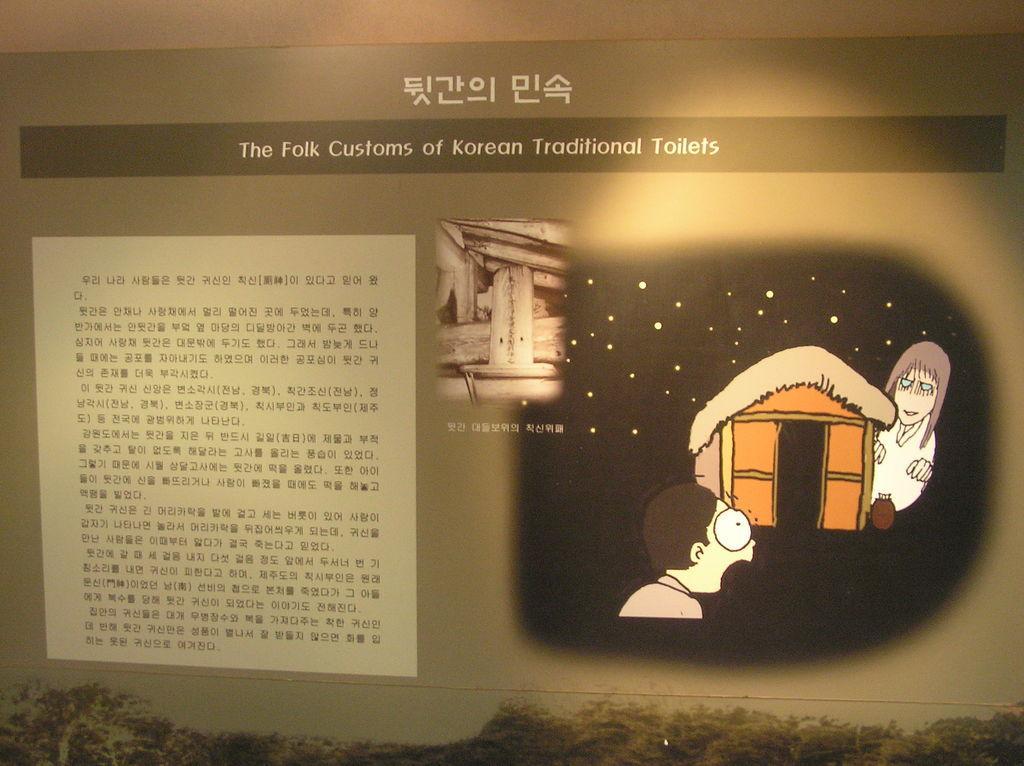In one or two sentences, can you explain what this image depicts? In this picture, it seems like a poster where we can see depiction and text. 